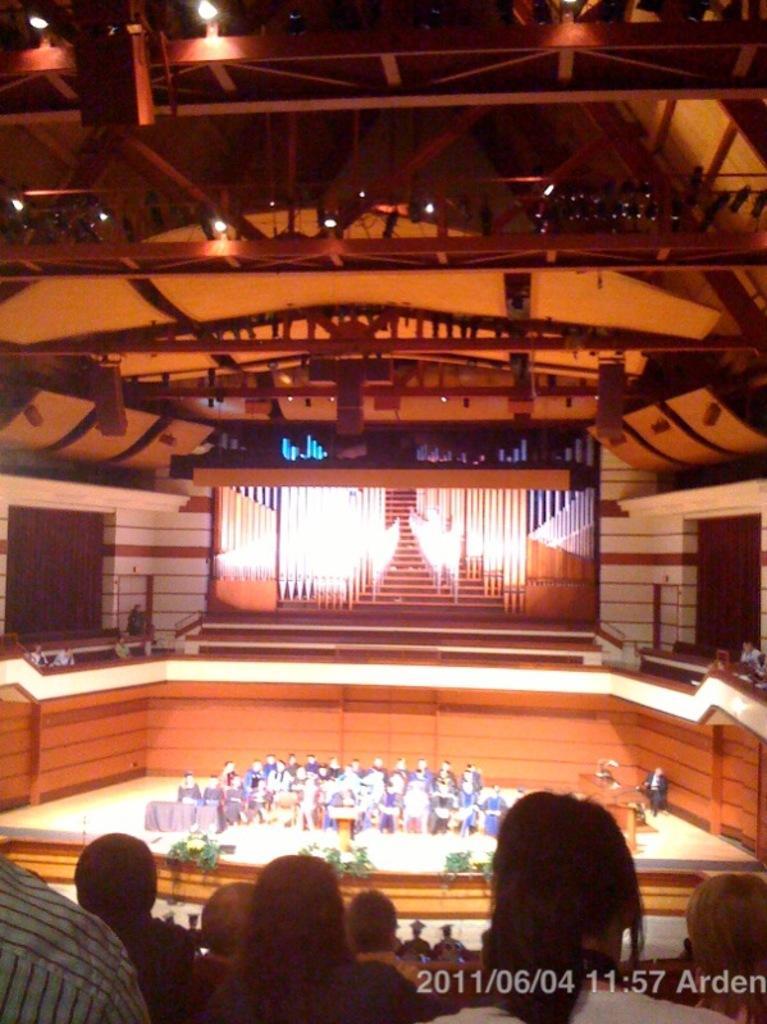Describe this image in one or two sentences. In the image it looks like there is some event being conducted in a hall, there are many people sitting on the stage and in front of the stage there is a huge crowd, there is a wooden wall around the stage and above that there is a screen displaying some visuals, there are many iron rods to the roof of the hall. 